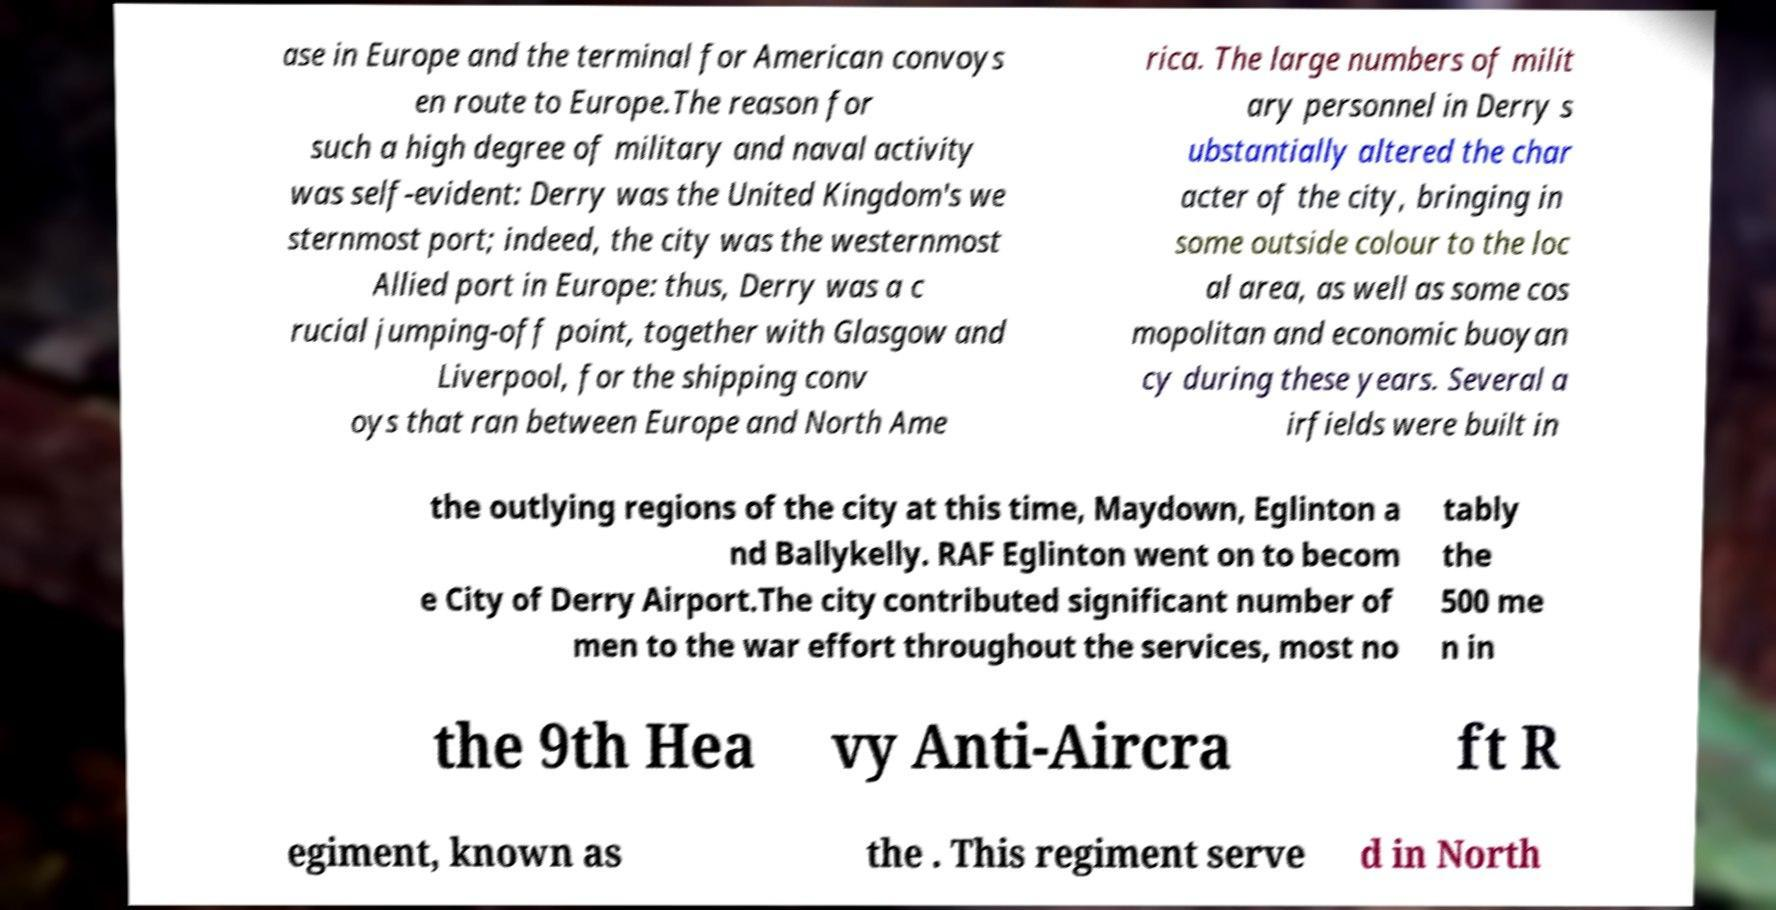For documentation purposes, I need the text within this image transcribed. Could you provide that? ase in Europe and the terminal for American convoys en route to Europe.The reason for such a high degree of military and naval activity was self-evident: Derry was the United Kingdom's we sternmost port; indeed, the city was the westernmost Allied port in Europe: thus, Derry was a c rucial jumping-off point, together with Glasgow and Liverpool, for the shipping conv oys that ran between Europe and North Ame rica. The large numbers of milit ary personnel in Derry s ubstantially altered the char acter of the city, bringing in some outside colour to the loc al area, as well as some cos mopolitan and economic buoyan cy during these years. Several a irfields were built in the outlying regions of the city at this time, Maydown, Eglinton a nd Ballykelly. RAF Eglinton went on to becom e City of Derry Airport.The city contributed significant number of men to the war effort throughout the services, most no tably the 500 me n in the 9th Hea vy Anti-Aircra ft R egiment, known as the . This regiment serve d in North 